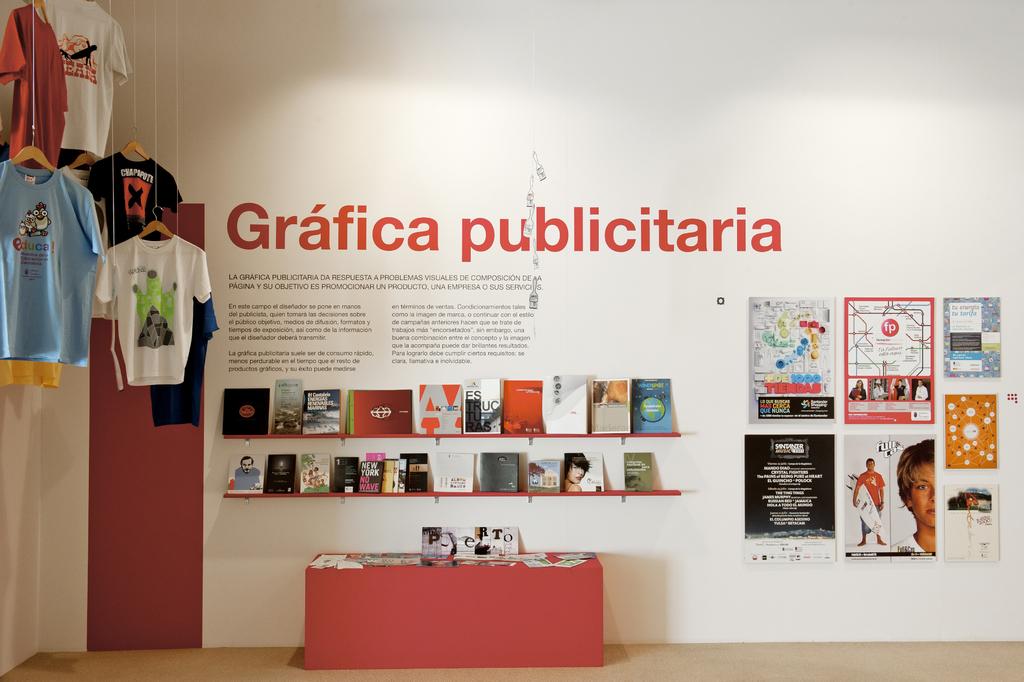What is the second word after grafica written in red on the wall?
Your response must be concise. Publicitaria. What two letters are in the red circle?
Ensure brevity in your answer.  Fp. 